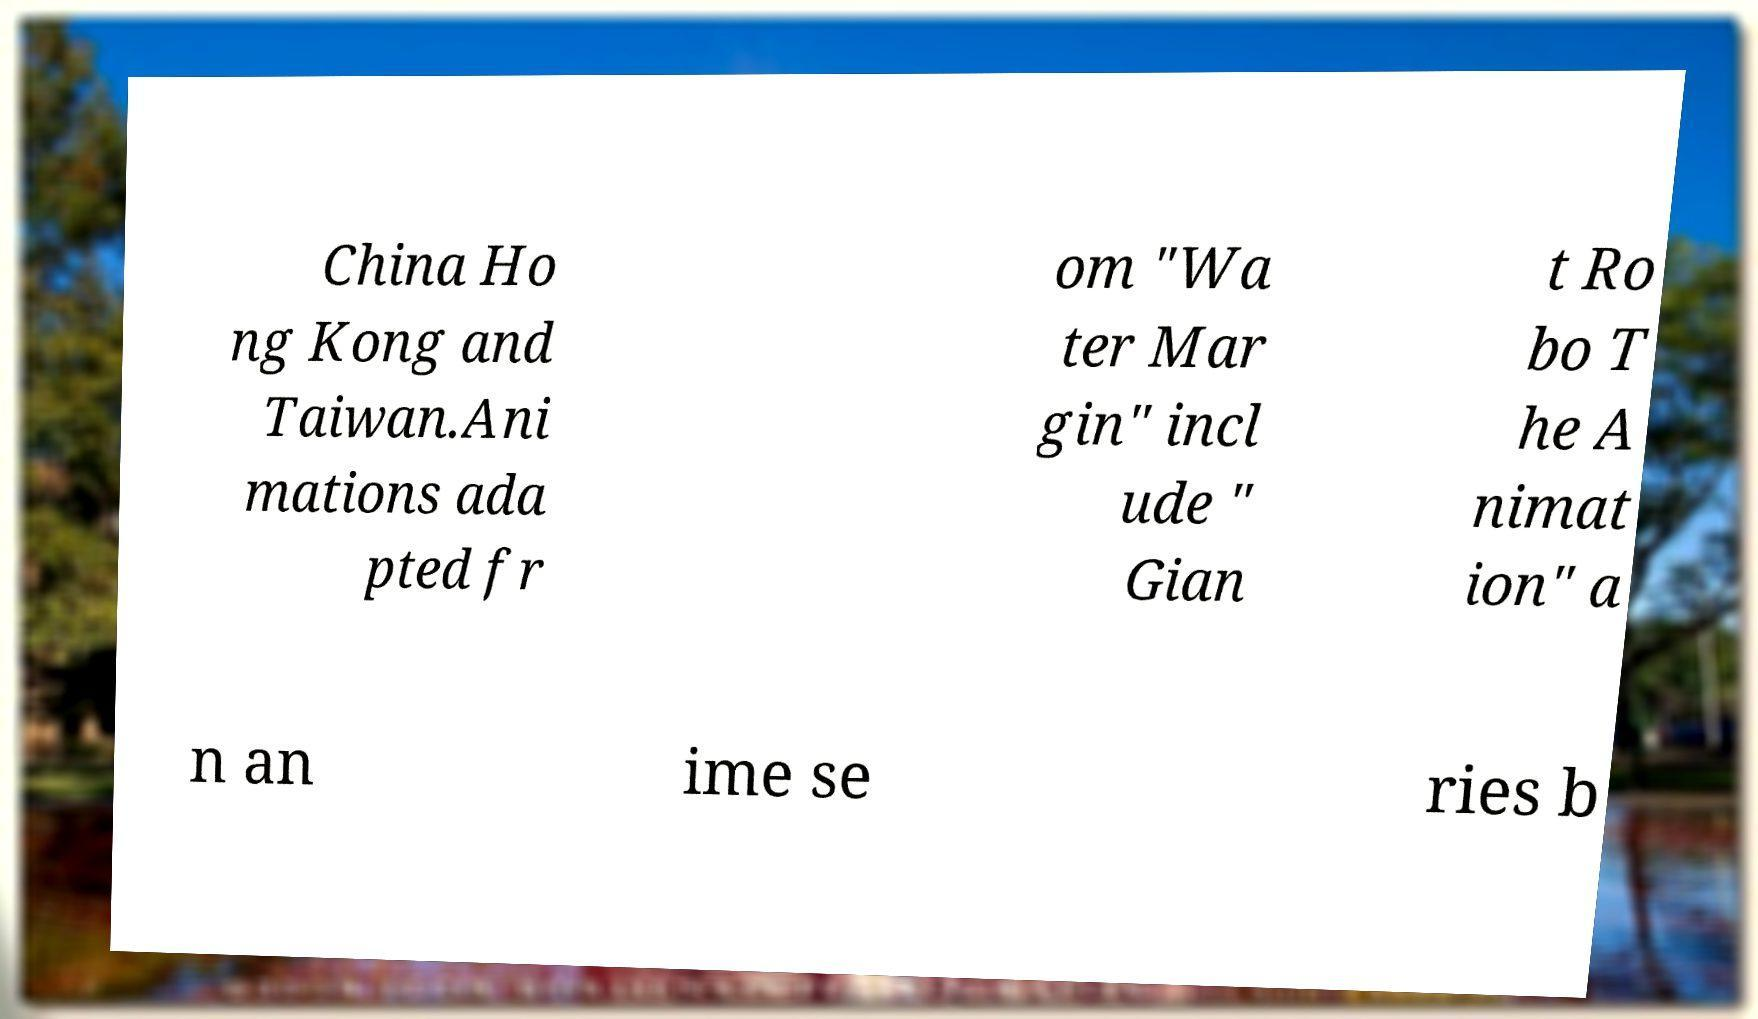Can you accurately transcribe the text from the provided image for me? China Ho ng Kong and Taiwan.Ani mations ada pted fr om "Wa ter Mar gin" incl ude " Gian t Ro bo T he A nimat ion" a n an ime se ries b 